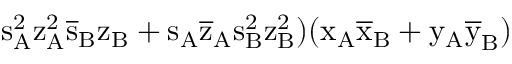<formula> <loc_0><loc_0><loc_500><loc_500>s _ { A } ^ { 2 } \mathrm { z _ { A } ^ { 2 } \mathrm { \overline { s } _ { B } \mathrm { z _ { B } + \mathrm { s _ { A } \mathrm { \overline { z } _ { A } \mathrm { s _ { B } ^ { 2 } \mathrm { z _ { B } ^ { 2 } ) ( \mathrm { x _ { A } \mathrm { \overline { x } _ { B } + \mathrm { y _ { A } \mathrm { \overline { y } _ { B } ) } } } } } } } } } } }</formula> 